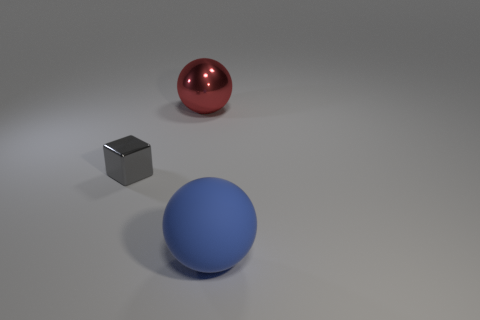Add 3 cyan matte cubes. How many objects exist? 6 Subtract all blocks. How many objects are left? 2 Subtract all large purple metal objects. Subtract all blocks. How many objects are left? 2 Add 1 large blue things. How many large blue things are left? 2 Add 3 large blue rubber things. How many large blue rubber things exist? 4 Subtract 0 green cylinders. How many objects are left? 3 